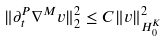<formula> <loc_0><loc_0><loc_500><loc_500>\| \partial _ { t } ^ { P } \nabla ^ { M } v \| _ { 2 } ^ { 2 } \leq C \| v \| _ { H _ { 0 } ^ { K } } ^ { 2 }</formula> 